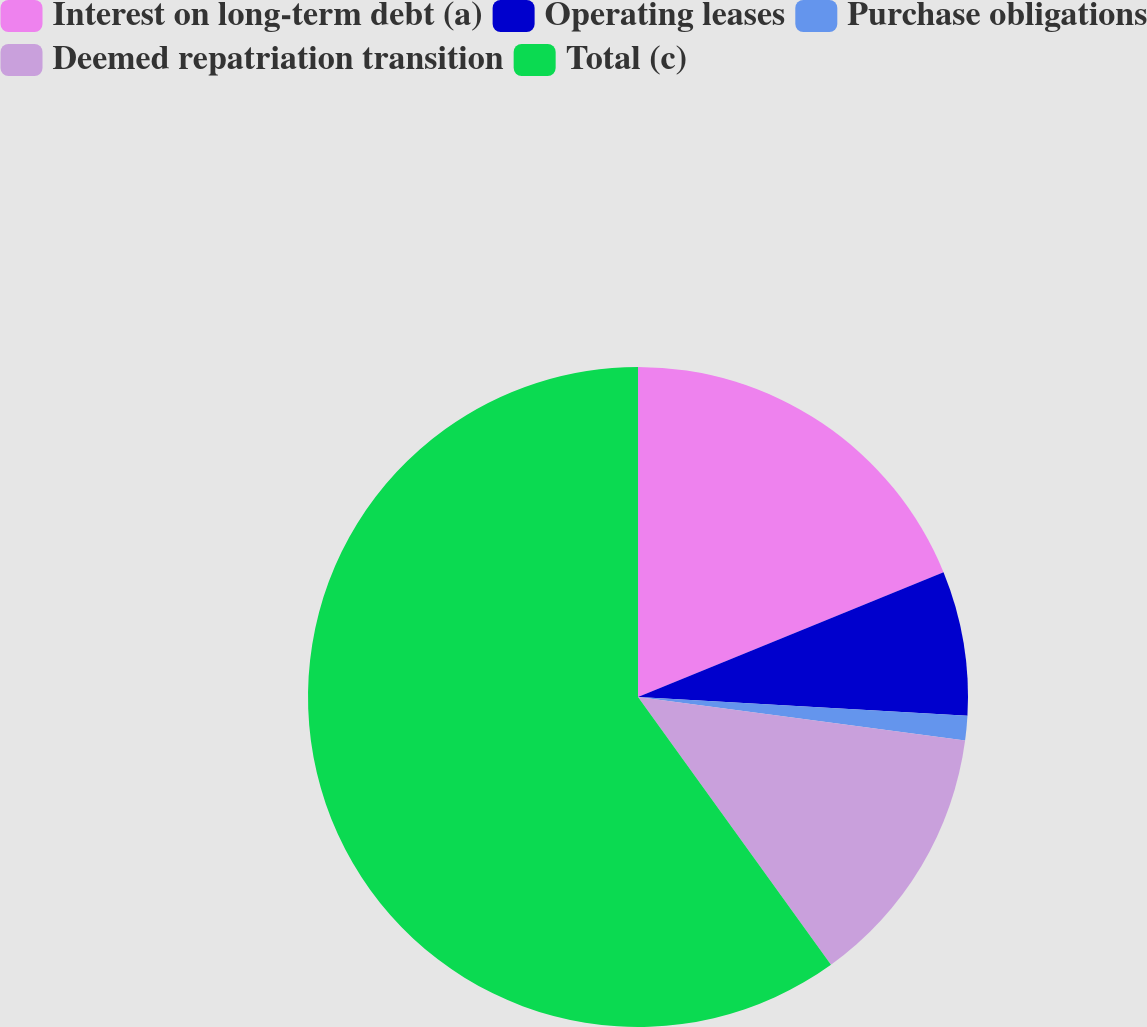Convert chart. <chart><loc_0><loc_0><loc_500><loc_500><pie_chart><fcel>Interest on long-term debt (a)<fcel>Operating leases<fcel>Purchase obligations<fcel>Deemed repatriation transition<fcel>Total (c)<nl><fcel>18.83%<fcel>7.08%<fcel>1.2%<fcel>12.95%<fcel>59.94%<nl></chart> 